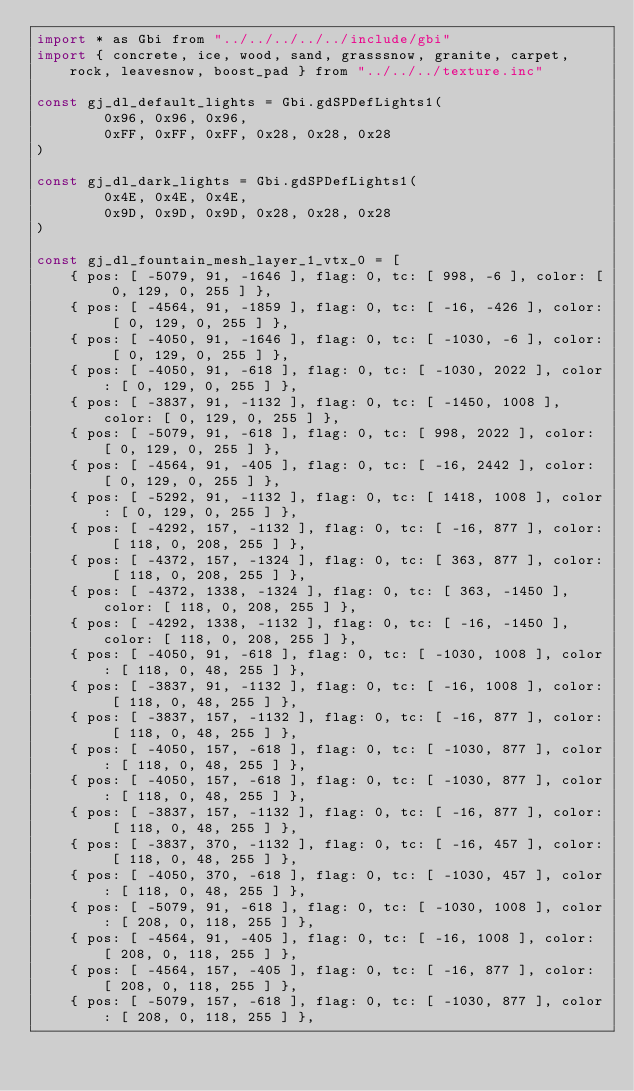Convert code to text. <code><loc_0><loc_0><loc_500><loc_500><_JavaScript_>import * as Gbi from "../../../../../include/gbi"
import { concrete, ice, wood, sand, grasssnow, granite, carpet, rock, leavesnow, boost_pad } from "../../../texture.inc"

const gj_dl_default_lights = Gbi.gdSPDefLights1(
        0x96, 0x96, 0x96,
		0xFF, 0xFF, 0xFF, 0x28, 0x28, 0x28
)

const gj_dl_dark_lights = Gbi.gdSPDefLights1(
		0x4E, 0x4E, 0x4E,
		0x9D, 0x9D, 0x9D, 0x28, 0x28, 0x28
)

const gj_dl_fountain_mesh_layer_1_vtx_0 = [
	{ pos: [ -5079, 91, -1646 ], flag: 0, tc: [ 998, -6 ], color: [ 0, 129, 0, 255 ] },
	{ pos: [ -4564, 91, -1859 ], flag: 0, tc: [ -16, -426 ], color: [ 0, 129, 0, 255 ] },
	{ pos: [ -4050, 91, -1646 ], flag: 0, tc: [ -1030, -6 ], color: [ 0, 129, 0, 255 ] },
	{ pos: [ -4050, 91, -618 ], flag: 0, tc: [ -1030, 2022 ], color: [ 0, 129, 0, 255 ] },
	{ pos: [ -3837, 91, -1132 ], flag: 0, tc: [ -1450, 1008 ], color: [ 0, 129, 0, 255 ] },
	{ pos: [ -5079, 91, -618 ], flag: 0, tc: [ 998, 2022 ], color: [ 0, 129, 0, 255 ] },
	{ pos: [ -4564, 91, -405 ], flag: 0, tc: [ -16, 2442 ], color: [ 0, 129, 0, 255 ] },
	{ pos: [ -5292, 91, -1132 ], flag: 0, tc: [ 1418, 1008 ], color: [ 0, 129, 0, 255 ] },
	{ pos: [ -4292, 157, -1132 ], flag: 0, tc: [ -16, 877 ], color: [ 118, 0, 208, 255 ] },
	{ pos: [ -4372, 157, -1324 ], flag: 0, tc: [ 363, 877 ], color: [ 118, 0, 208, 255 ] },
	{ pos: [ -4372, 1338, -1324 ], flag: 0, tc: [ 363, -1450 ], color: [ 118, 0, 208, 255 ] },
	{ pos: [ -4292, 1338, -1132 ], flag: 0, tc: [ -16, -1450 ], color: [ 118, 0, 208, 255 ] },
	{ pos: [ -4050, 91, -618 ], flag: 0, tc: [ -1030, 1008 ], color: [ 118, 0, 48, 255 ] },
	{ pos: [ -3837, 91, -1132 ], flag: 0, tc: [ -16, 1008 ], color: [ 118, 0, 48, 255 ] },
	{ pos: [ -3837, 157, -1132 ], flag: 0, tc: [ -16, 877 ], color: [ 118, 0, 48, 255 ] },
	{ pos: [ -4050, 157, -618 ], flag: 0, tc: [ -1030, 877 ], color: [ 118, 0, 48, 255 ] },
	{ pos: [ -4050, 157, -618 ], flag: 0, tc: [ -1030, 877 ], color: [ 118, 0, 48, 255 ] },
	{ pos: [ -3837, 157, -1132 ], flag: 0, tc: [ -16, 877 ], color: [ 118, 0, 48, 255 ] },
	{ pos: [ -3837, 370, -1132 ], flag: 0, tc: [ -16, 457 ], color: [ 118, 0, 48, 255 ] },
	{ pos: [ -4050, 370, -618 ], flag: 0, tc: [ -1030, 457 ], color: [ 118, 0, 48, 255 ] },
	{ pos: [ -5079, 91, -618 ], flag: 0, tc: [ -1030, 1008 ], color: [ 208, 0, 118, 255 ] },
	{ pos: [ -4564, 91, -405 ], flag: 0, tc: [ -16, 1008 ], color: [ 208, 0, 118, 255 ] },
	{ pos: [ -4564, 157, -405 ], flag: 0, tc: [ -16, 877 ], color: [ 208, 0, 118, 255 ] },
	{ pos: [ -5079, 157, -618 ], flag: 0, tc: [ -1030, 877 ], color: [ 208, 0, 118, 255 ] },</code> 